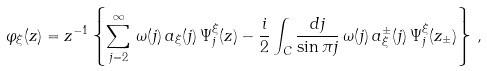<formula> <loc_0><loc_0><loc_500><loc_500>\varphi _ { \xi } ( z ) = z ^ { - 1 } \left \{ \sum _ { j = 2 } ^ { \infty } \, \omega ( j ) \, a _ { \xi } ( j ) \, \Psi _ { j } ^ { \xi } ( z ) - \frac { i } { 2 } \int _ { C } \frac { d j } { \sin \pi j } \, { \omega ( j ) } \, a ^ { \pm } _ { \xi } ( j ) \, \Psi _ { j } ^ { \xi } ( z _ { \pm } ) \right \} \, ,</formula> 